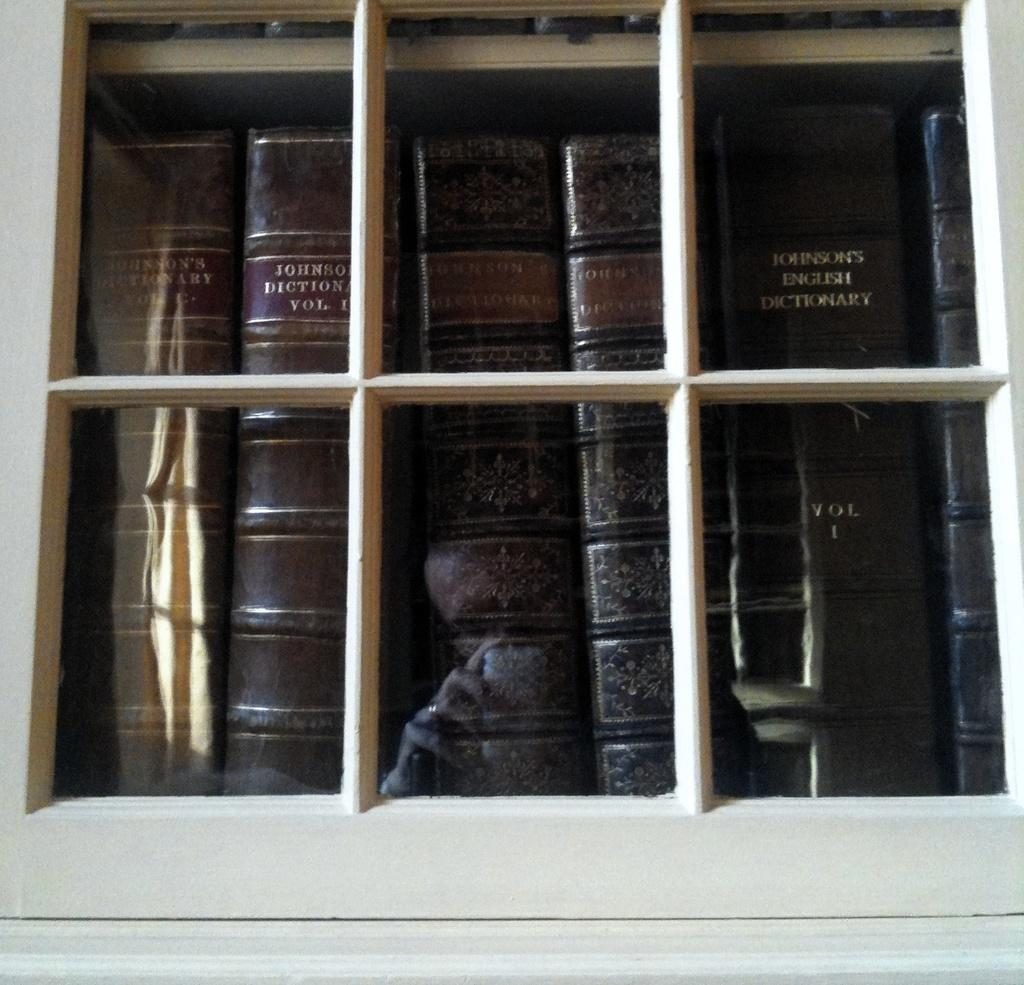<image>
Present a compact description of the photo's key features. Several volumes of Jonson's English Dictionary are in a glass-front shelf. 